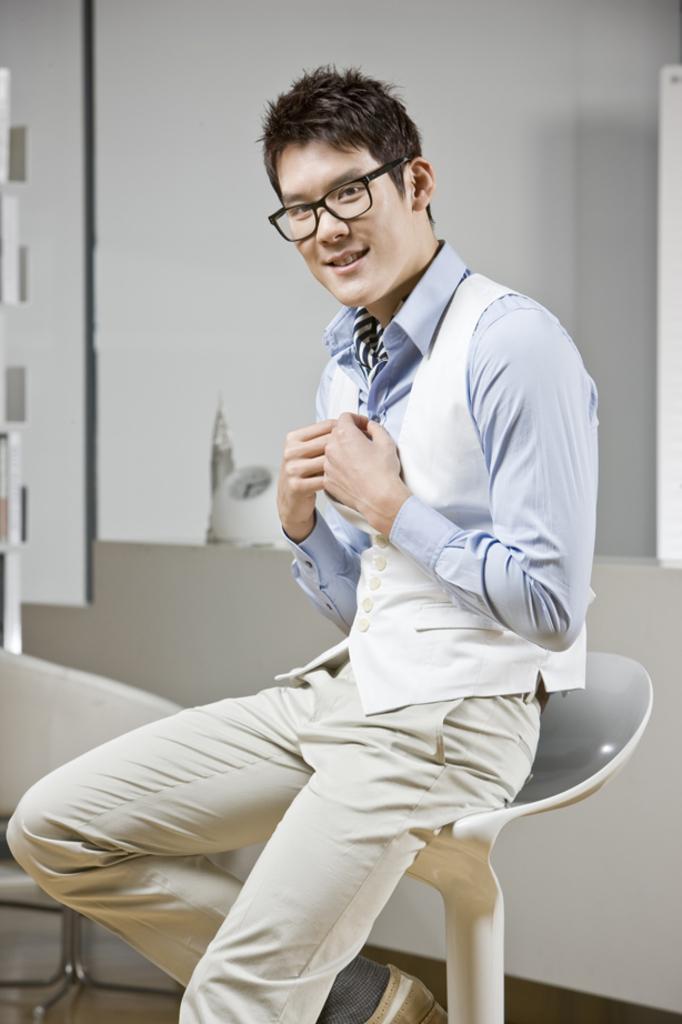In one or two sentences, can you explain what this image depicts? In this picture we can see a person, he is sitting on a chair and in the background we can see a wall and some objects. 